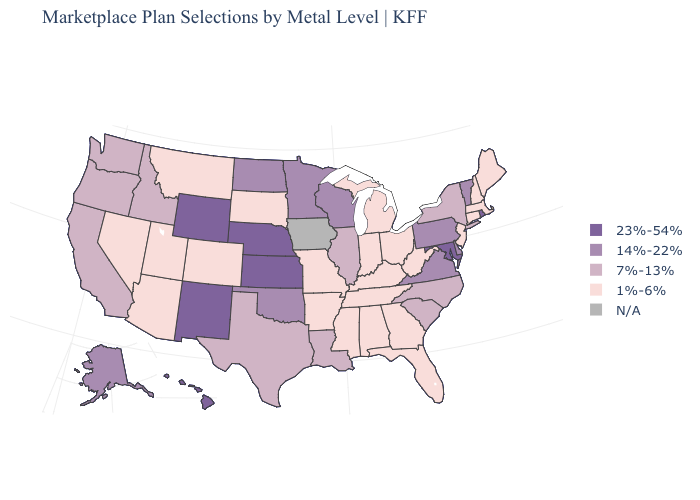Which states have the lowest value in the USA?
Short answer required. Alabama, Arizona, Arkansas, Colorado, Connecticut, Florida, Georgia, Indiana, Kentucky, Maine, Massachusetts, Michigan, Mississippi, Missouri, Montana, Nevada, New Hampshire, New Jersey, Ohio, South Dakota, Tennessee, Utah, West Virginia. Which states have the lowest value in the USA?
Concise answer only. Alabama, Arizona, Arkansas, Colorado, Connecticut, Florida, Georgia, Indiana, Kentucky, Maine, Massachusetts, Michigan, Mississippi, Missouri, Montana, Nevada, New Hampshire, New Jersey, Ohio, South Dakota, Tennessee, Utah, West Virginia. Name the states that have a value in the range 23%-54%?
Short answer required. Hawaii, Kansas, Maryland, Nebraska, New Mexico, Rhode Island, Wyoming. What is the highest value in the USA?
Short answer required. 23%-54%. Does Wyoming have the highest value in the USA?
Write a very short answer. Yes. Does North Carolina have the highest value in the USA?
Be succinct. No. What is the value of Minnesota?
Write a very short answer. 14%-22%. Does Vermont have the lowest value in the Northeast?
Write a very short answer. No. Which states have the lowest value in the USA?
Answer briefly. Alabama, Arizona, Arkansas, Colorado, Connecticut, Florida, Georgia, Indiana, Kentucky, Maine, Massachusetts, Michigan, Mississippi, Missouri, Montana, Nevada, New Hampshire, New Jersey, Ohio, South Dakota, Tennessee, Utah, West Virginia. How many symbols are there in the legend?
Short answer required. 5. Does Texas have the lowest value in the South?
Give a very brief answer. No. What is the value of Colorado?
Give a very brief answer. 1%-6%. Name the states that have a value in the range 7%-13%?
Concise answer only. California, Idaho, Illinois, Louisiana, New York, North Carolina, Oregon, South Carolina, Texas, Washington. What is the value of Arizona?
Write a very short answer. 1%-6%. 